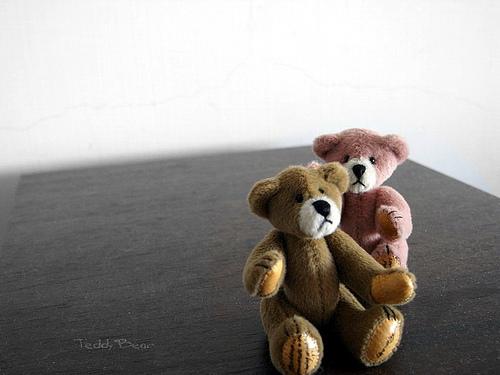Is there anyone in the photo?
Answer briefly. No. How many bears are there?
Short answer required. 2. Is the bear made of wood?
Concise answer only. No. 